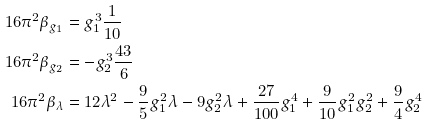<formula> <loc_0><loc_0><loc_500><loc_500>1 6 \pi ^ { 2 } \beta _ { g _ { 1 } } & = g _ { 1 } ^ { 3 } \frac { 1 } { 1 0 } \\ 1 6 \pi ^ { 2 } \beta _ { g _ { 2 } } & = - g _ { 2 } ^ { 3 } \frac { 4 3 } { 6 } \\ 1 6 \pi ^ { 2 } \beta _ { \lambda } & = 1 2 \lambda ^ { 2 } - \frac { 9 } { 5 } g _ { 1 } ^ { 2 } \lambda - 9 g _ { 2 } ^ { 2 } \lambda + \frac { 2 7 } { 1 0 0 } g _ { 1 } ^ { 4 } + \frac { 9 } { 1 0 } g _ { 1 } ^ { 2 } g _ { 2 } ^ { 2 } + \frac { 9 } { 4 } g _ { 2 } ^ { 4 }</formula> 